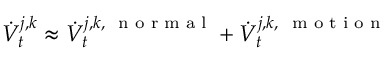Convert formula to latex. <formula><loc_0><loc_0><loc_500><loc_500>\dot { V } _ { t } ^ { j , k } \approx \dot { V } _ { t } ^ { j , k , n o r m a l } + \dot { V } _ { t } ^ { j , k , m o t i o n }</formula> 